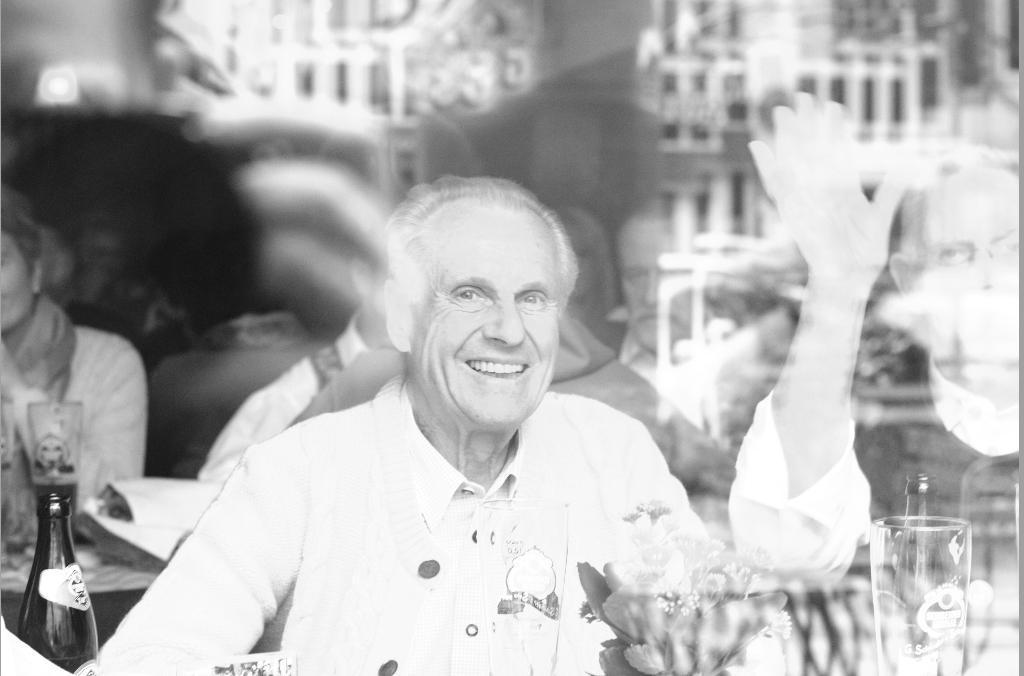How would you summarize this image in a sentence or two? A man is sitting here there is a wine bottle in the left and a glass in the right side of an image and other man is also waving his hand in the right there are few people sitting behind them. 